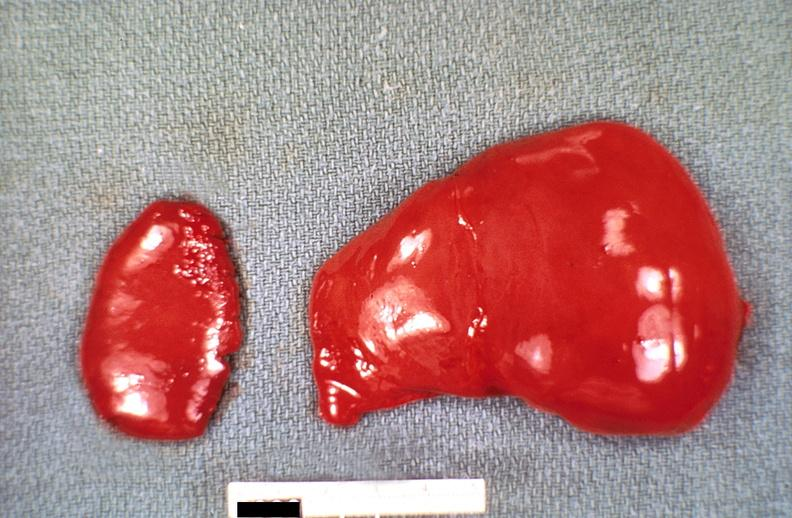s angiogram saphenous vein bypass graft present?
Answer the question using a single word or phrase. No 